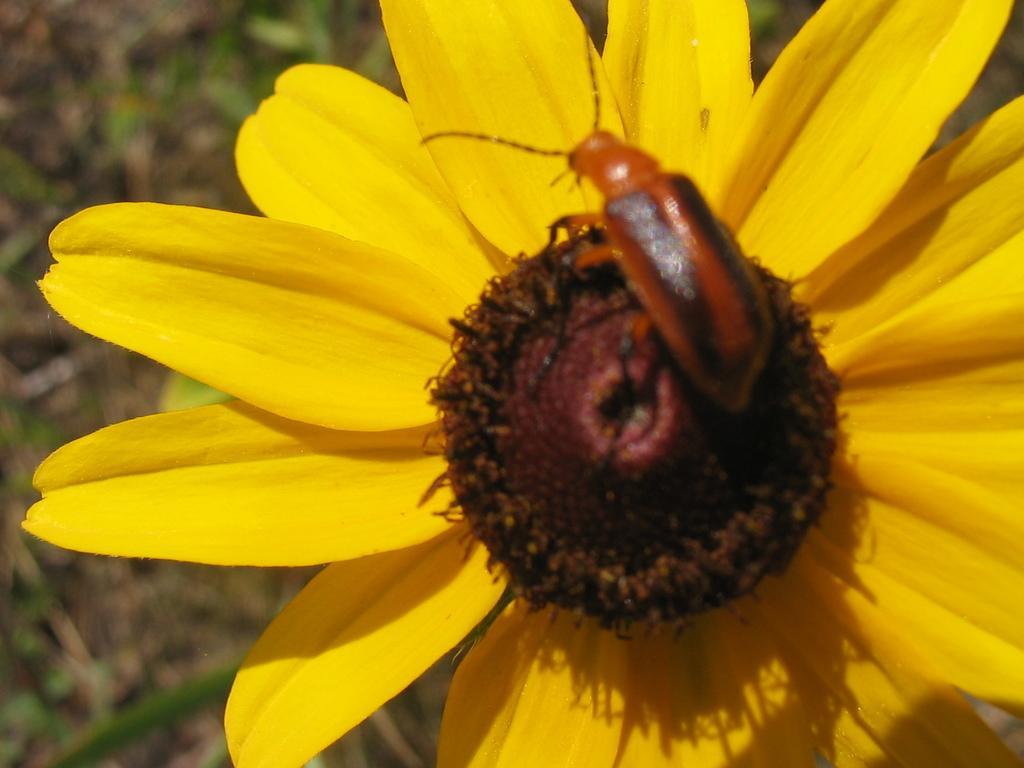Describe this image in one or two sentences. Insect is on flower. Background it is blur. 